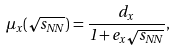<formula> <loc_0><loc_0><loc_500><loc_500>\mu _ { x } ( \sqrt { s _ { N N } } ) = \frac { d _ { x } } { 1 + e _ { x } \sqrt { s _ { N N } } } ,</formula> 